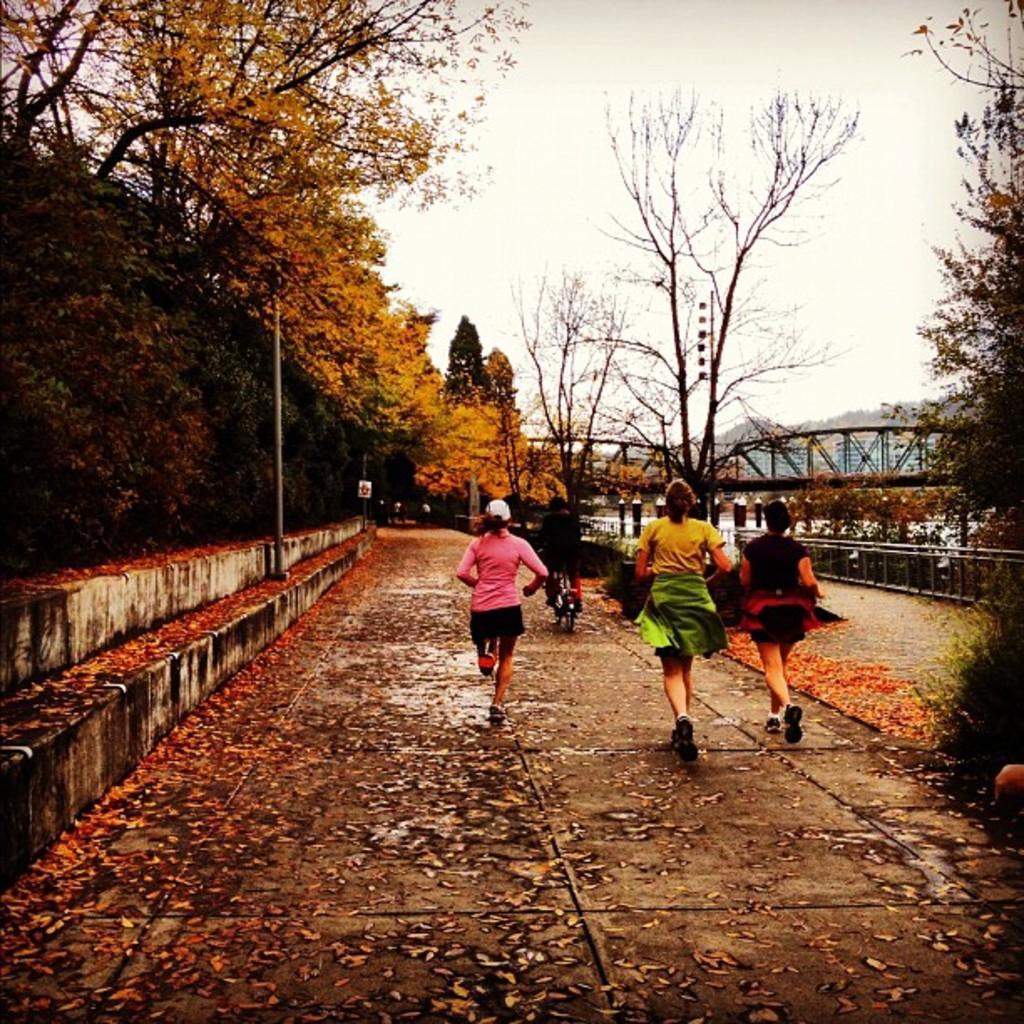How many women are present in the image? There are three women in the image. What are the women doing in the image? The women are running in a path. What can be seen on the ground in the image? There are dried leaves on the land. What structure is visible in the image? There is a bridge in the image. What is visible in the background of the image? There are trees and the sky in the background of the image. What type of tree can be seen in the aftermath of the winter season in the image? There is no tree present in the image, and the image does not depict an aftermath of winter. 